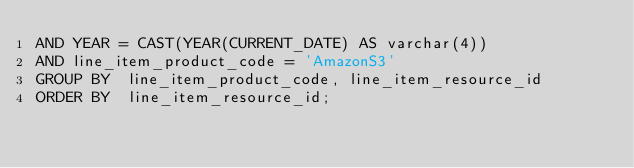Convert code to text. <code><loc_0><loc_0><loc_500><loc_500><_SQL_>AND YEAR = CAST(YEAR(CURRENT_DATE) AS varchar(4))
AND line_item_product_code = 'AmazonS3'
GROUP BY  line_item_product_code, line_item_resource_id
ORDER BY  line_item_resource_id;
</code> 